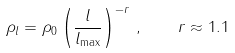<formula> <loc_0><loc_0><loc_500><loc_500>\rho _ { l } = \rho _ { 0 } \left ( \frac { l } { l _ { \max } } \right ) ^ { - r } \, , \quad r \approx 1 . 1</formula> 